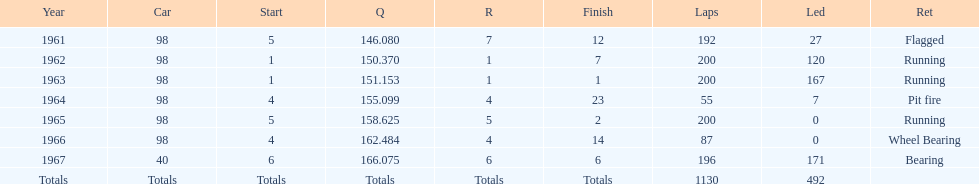Could you parse the entire table as a dict? {'header': ['Year', 'Car', 'Start', 'Q', 'R', 'Finish', 'Laps', 'Led', 'Ret'], 'rows': [['1961', '98', '5', '146.080', '7', '12', '192', '27', 'Flagged'], ['1962', '98', '1', '150.370', '1', '7', '200', '120', 'Running'], ['1963', '98', '1', '151.153', '1', '1', '200', '167', 'Running'], ['1964', '98', '4', '155.099', '4', '23', '55', '7', 'Pit fire'], ['1965', '98', '5', '158.625', '5', '2', '200', '0', 'Running'], ['1966', '98', '4', '162.484', '4', '14', '87', '0', 'Wheel Bearing'], ['1967', '40', '6', '166.075', '6', '6', '196', '171', 'Bearing'], ['Totals', 'Totals', 'Totals', 'Totals', 'Totals', 'Totals', '1130', '492', '']]} In which years did he lead the race the least? 1965, 1966. 